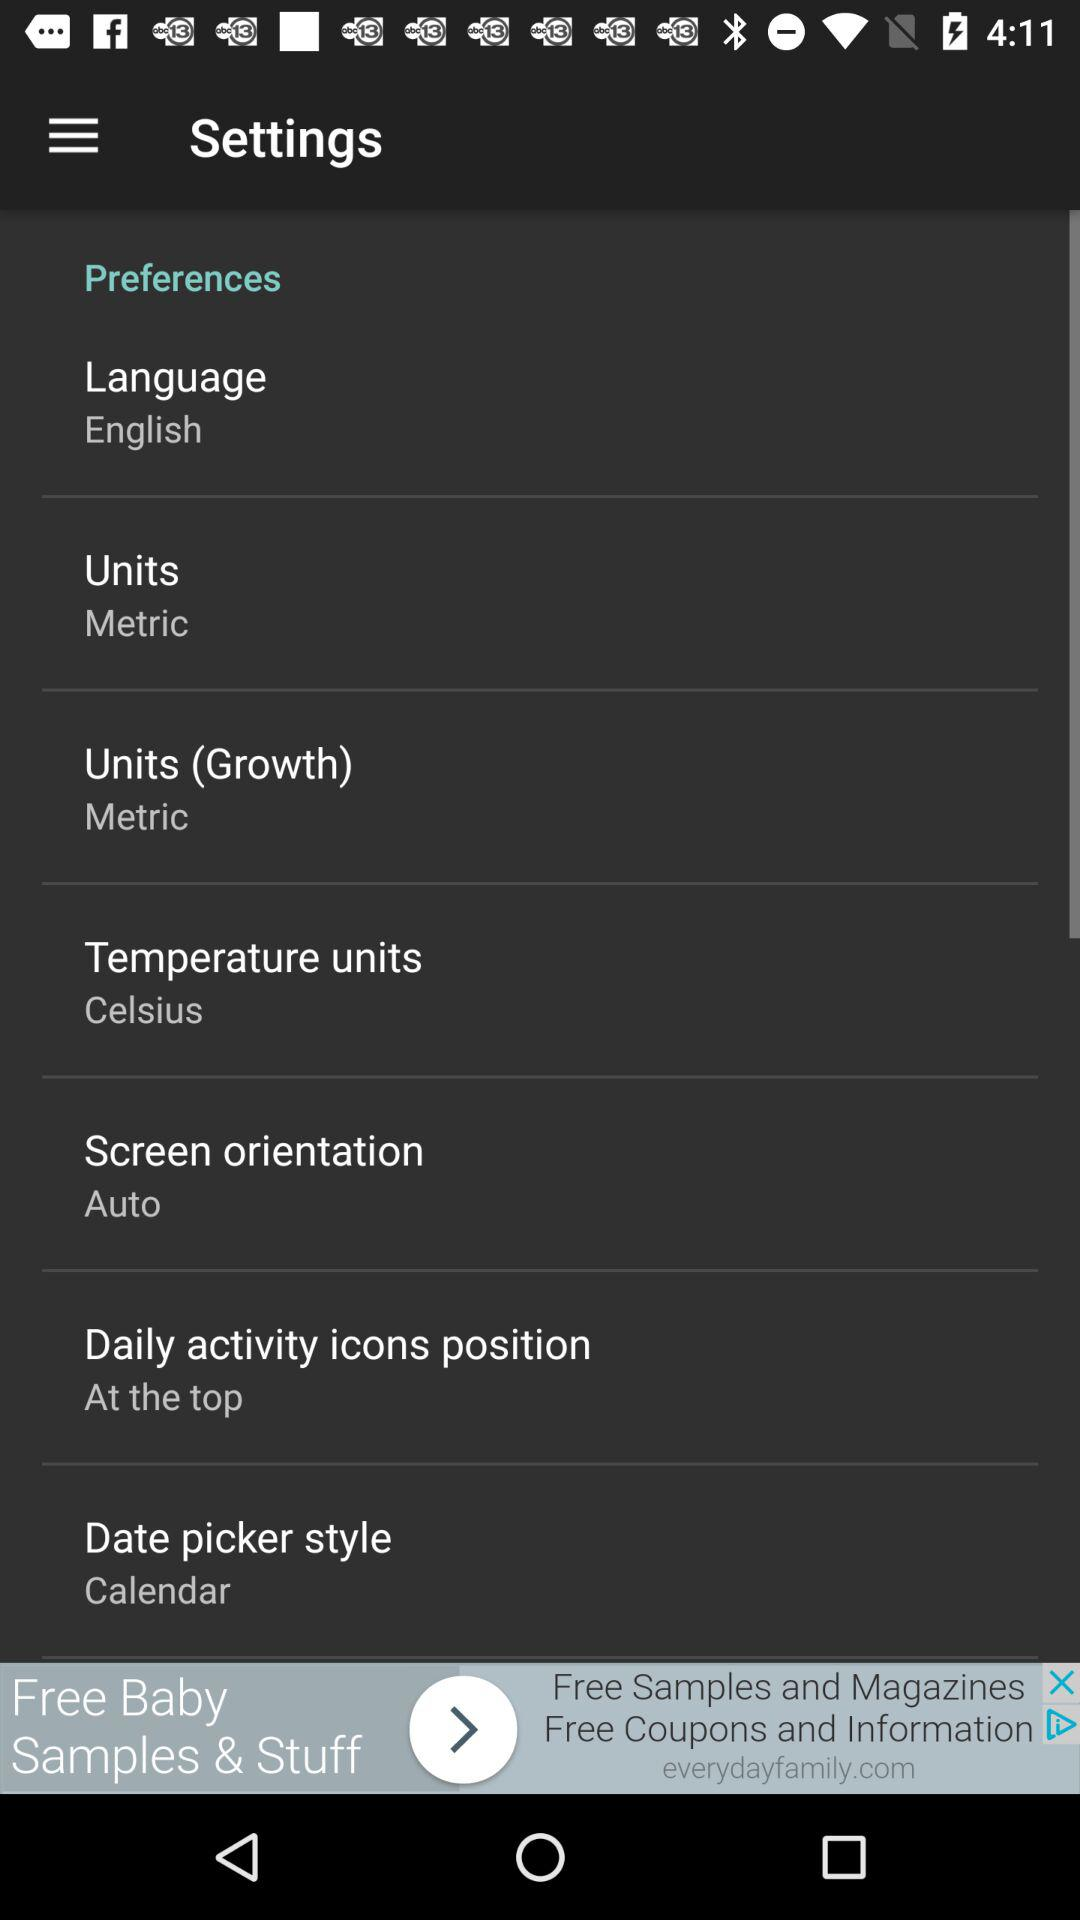Which language is selected? The selected language is English. 